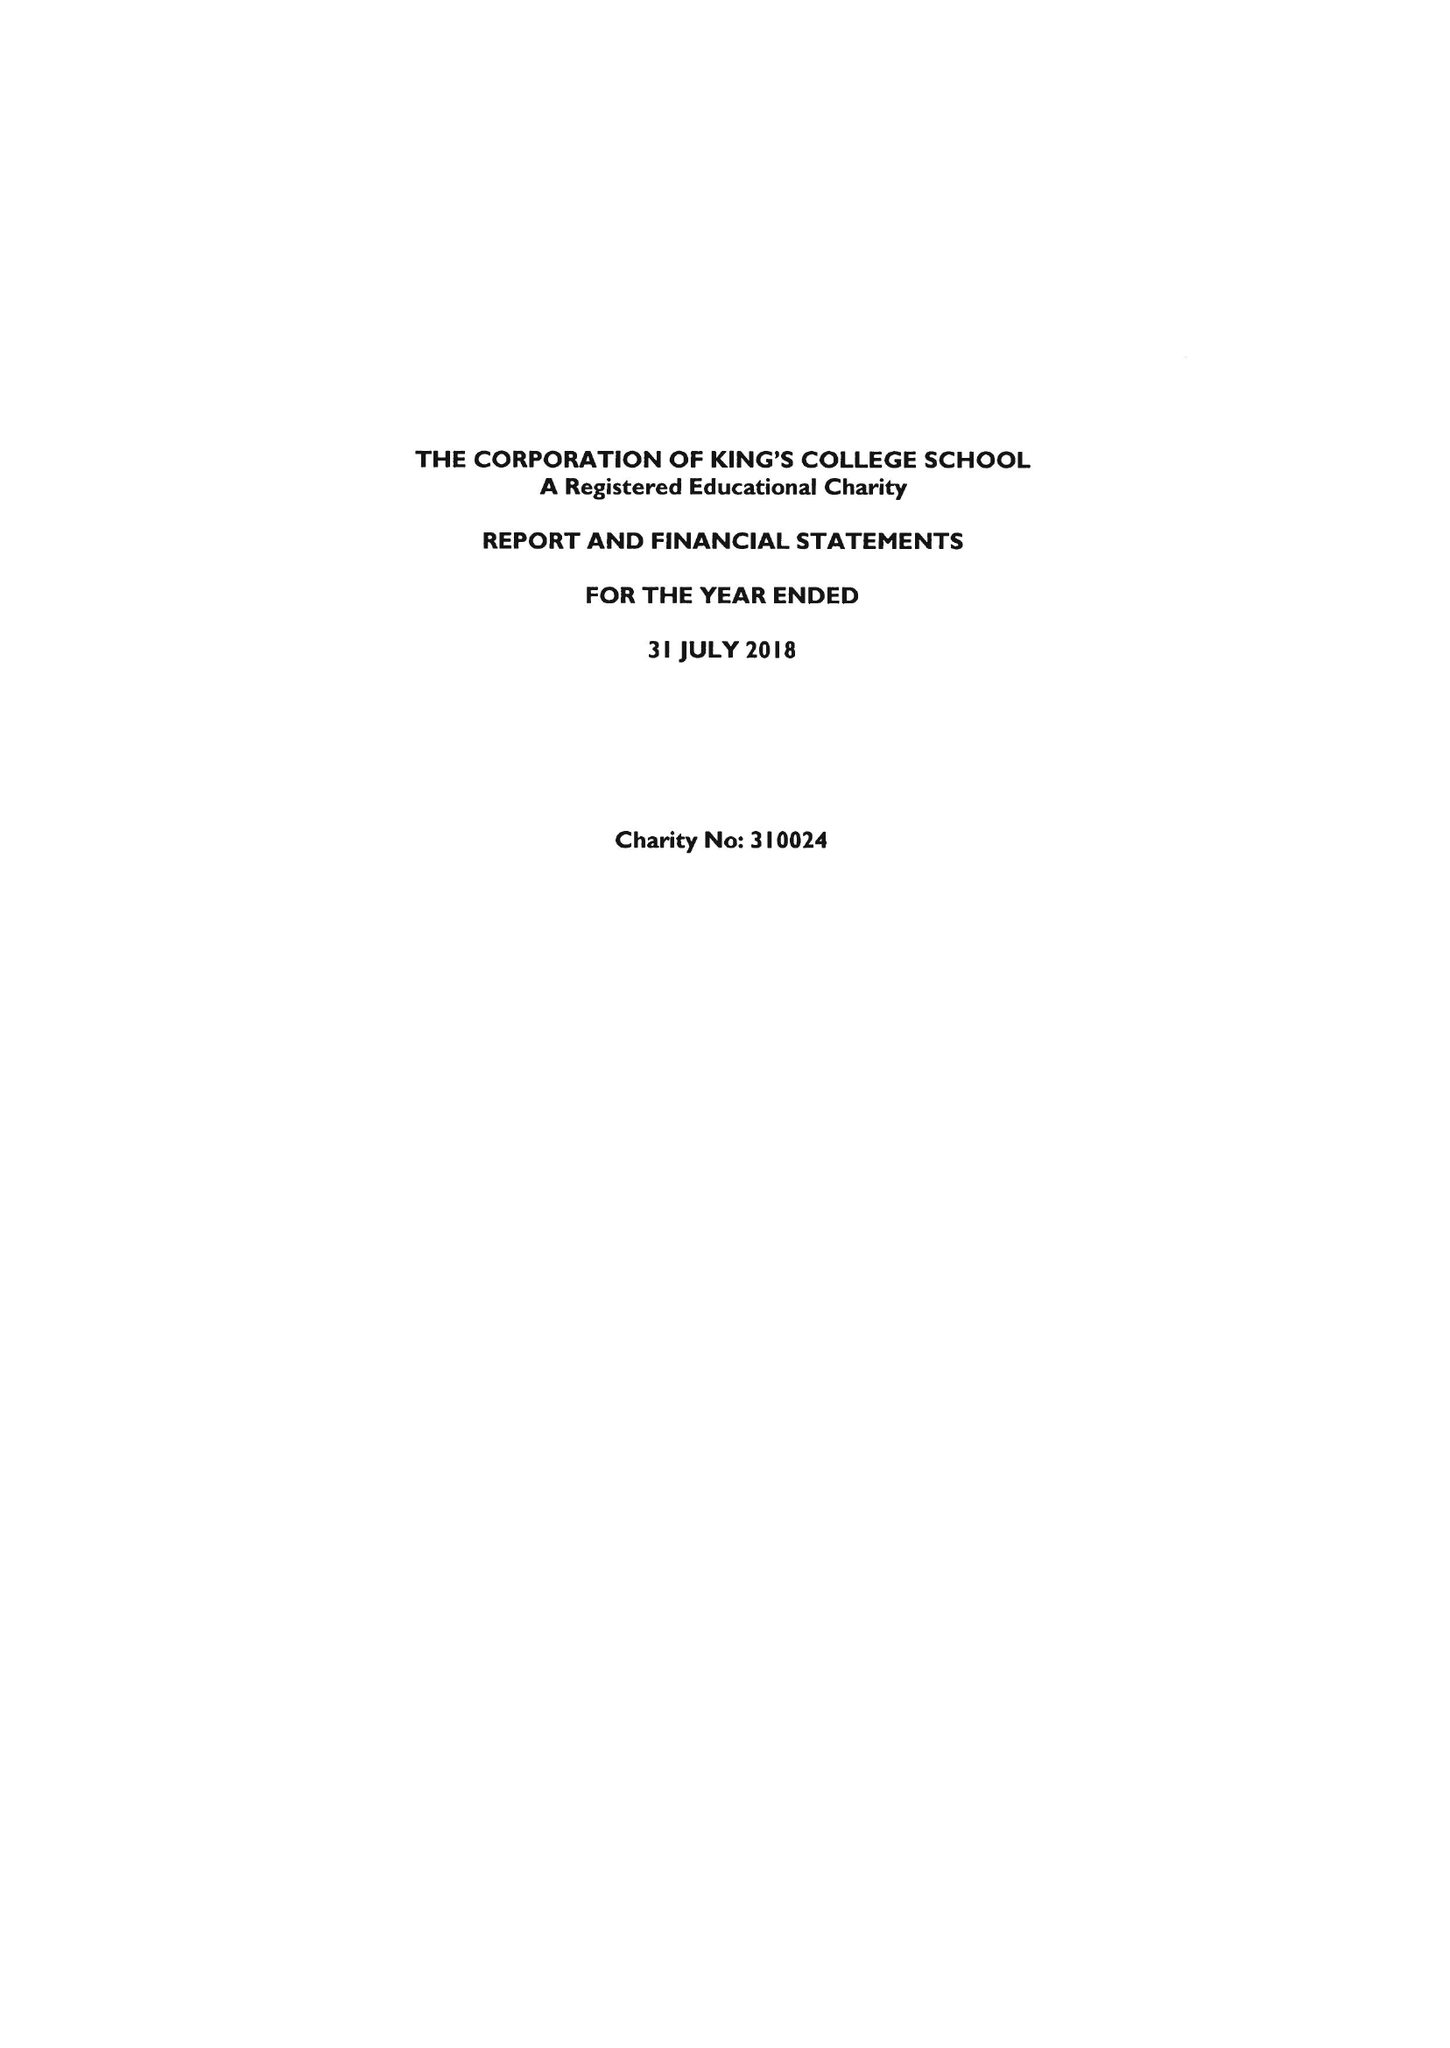What is the value for the spending_annually_in_british_pounds?
Answer the question using a single word or phrase. 29013000.00 